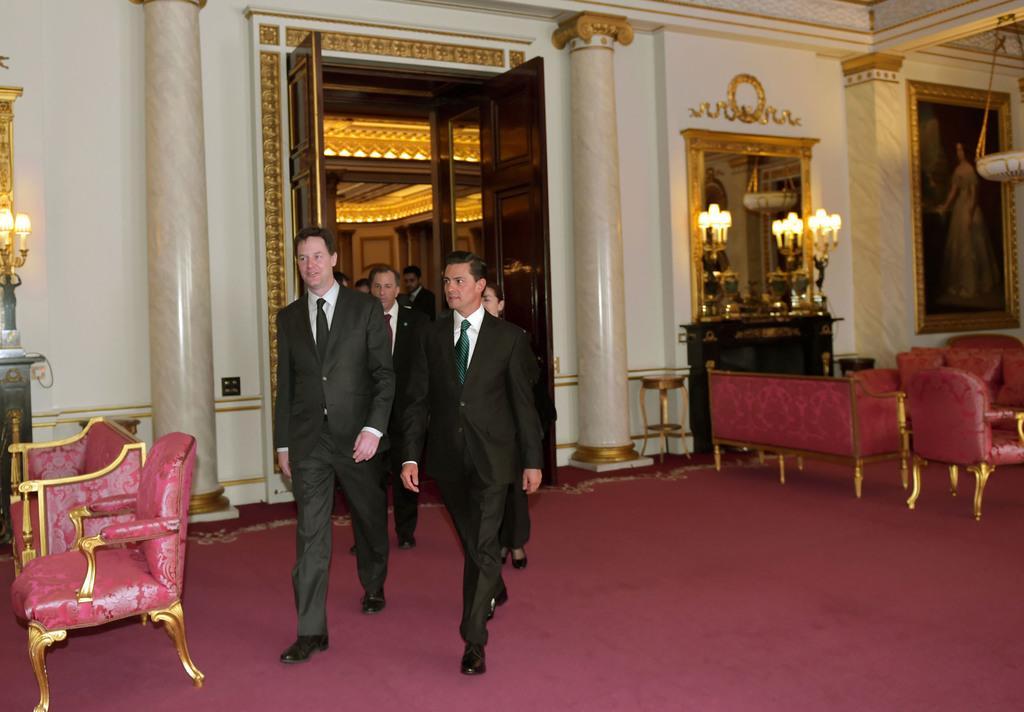Please provide a concise description of this image. In this picture I can see the inside view of a building and I can see the floor in front and on the floor I can see few men wearing formal dress and on the both side of this image, I can see the chairs. In the background I can see the wall and I can see few lights. On the right side of this picture I can see a mirror and a photo frame. 